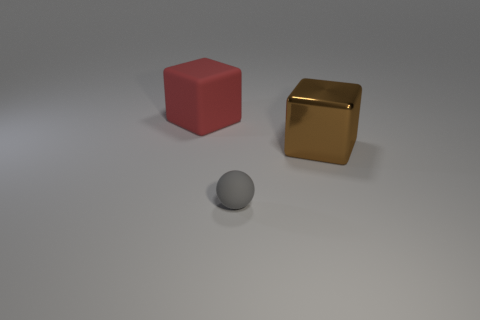Add 2 large gray things. How many objects exist? 5 Subtract all balls. How many objects are left? 2 Add 2 large purple metal cubes. How many large purple metal cubes exist? 2 Subtract 0 yellow cubes. How many objects are left? 3 Subtract all purple shiny spheres. Subtract all large brown shiny cubes. How many objects are left? 2 Add 3 large cubes. How many large cubes are left? 5 